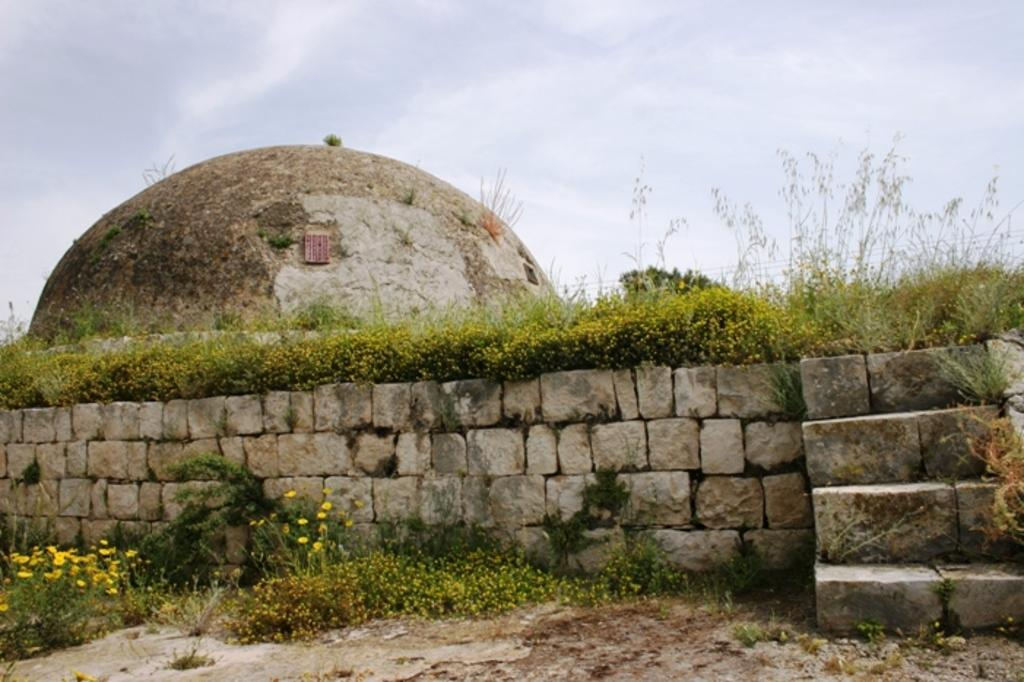What is located at the bottom side of the image? There is a wall at the bottom side of the image. What can be seen on the right side of the image? There are stairs on the right side of the image. What type of vegetation or plants can be seen in the image? There is greenery in the image. Can you see an apple on the tongue of someone in the image? There is no apple or tongue visible in the image. Is there a ship sailing in the background of the image? There is no ship present in the image. 